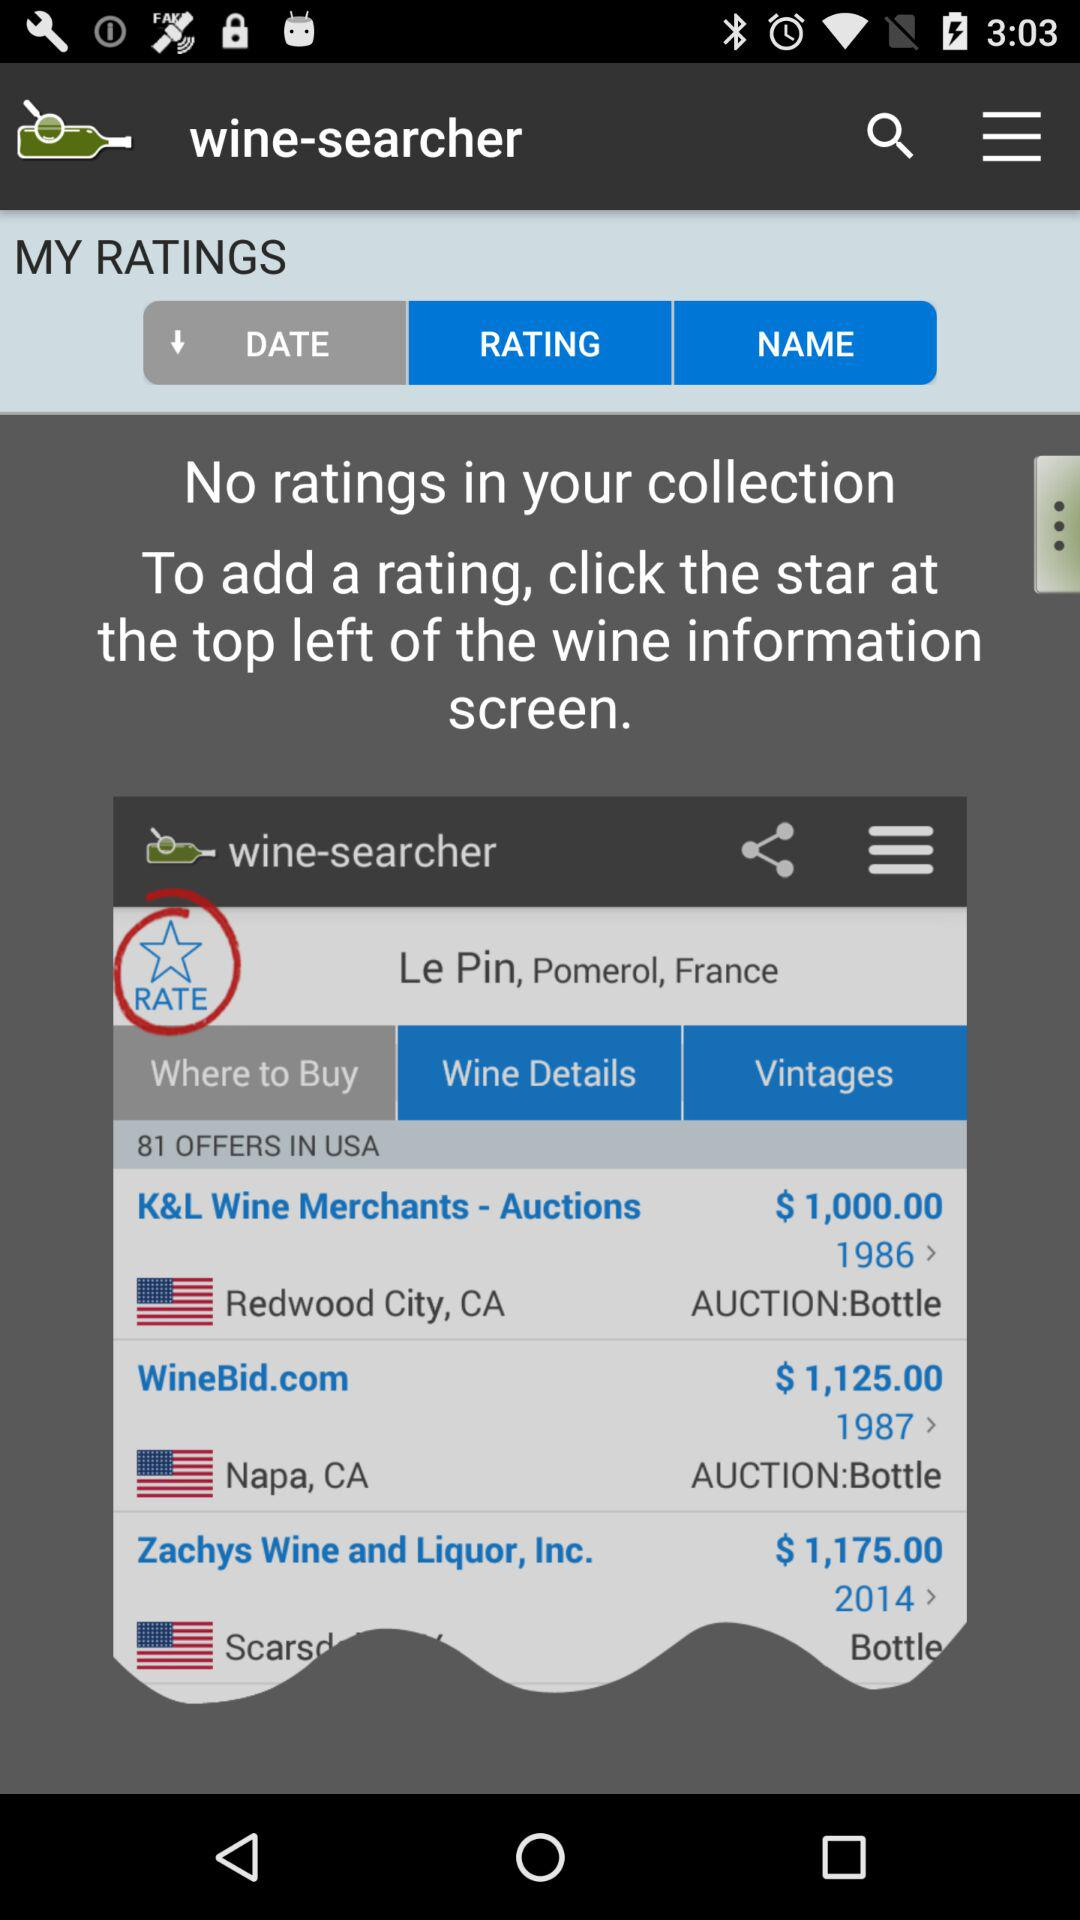What is the price difference between the cheapest and most expensive offers?
Answer the question using a single word or phrase. $175.00 